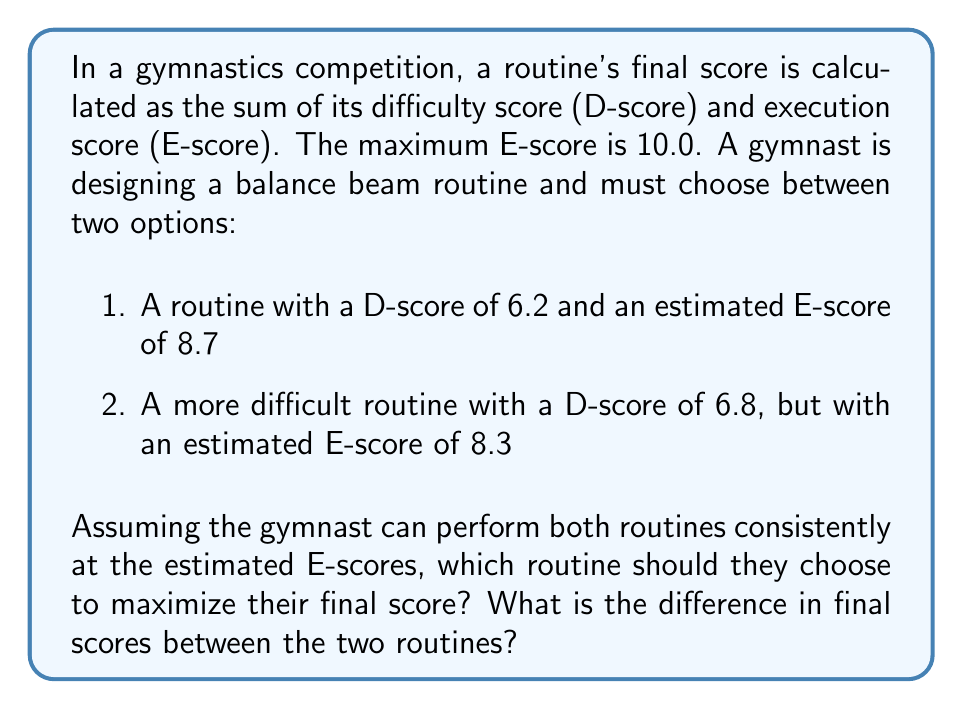Give your solution to this math problem. To solve this problem, we need to calculate the final score for each routine and compare them:

1. For the first routine:
   D-score = 6.2
   E-score = 8.7
   Final score = D-score + E-score = 6.2 + 8.7 = 14.9

2. For the second routine:
   D-score = 6.8
   E-score = 8.3
   Final score = D-score + E-score = 6.8 + 8.3 = 15.1

To find the difference in final scores:
Difference = Second routine score - First routine score
           = 15.1 - 14.9 = 0.2

The second routine yields a higher final score, despite having a lower E-score. This illustrates the trade-off between difficulty and execution in gymnastics scoring. The increase in D-score (0.6 points) outweighs the decrease in E-score (0.4 points), resulting in a net gain of 0.2 points.
Answer: The gymnast should choose the second, more difficult routine to maximize their final score. The difference in final scores between the two routines is 0.2 points in favor of the more difficult routine. 